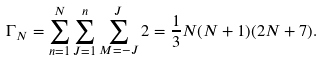<formula> <loc_0><loc_0><loc_500><loc_500>\Gamma _ { N } = \sum _ { n = 1 } ^ { N } \sum _ { J = 1 } ^ { n } \sum _ { M = - J } ^ { J } 2 = \frac { 1 } { 3 } N ( N + 1 ) ( 2 N + 7 ) .</formula> 